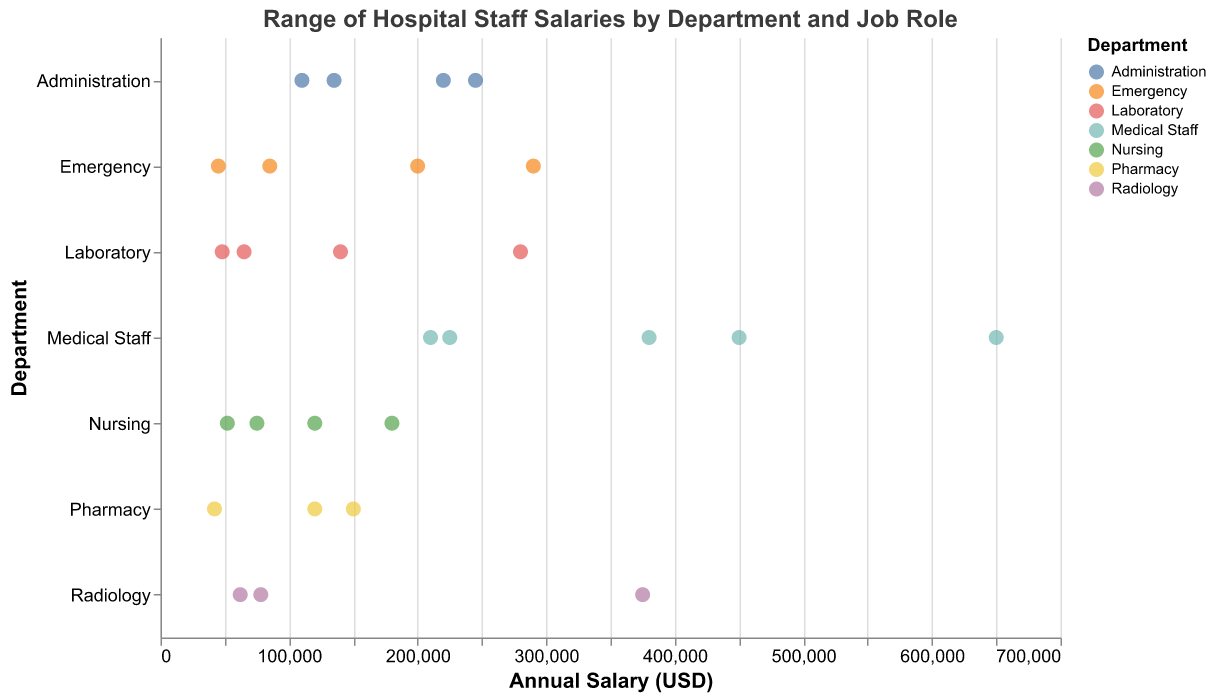What is the annual salary of a Chief Financial Officer in the Administration department? Look at the Administration department row and find the Chief Financial Officer job role, then view the salary value.
Answer: 220000 Which department has the highest-paid job role, and what is the salary? Identify the highest salary in the entire plot and note the department and job role corresponding to it.
Answer: Medical Staff, 650000 What is the range of salaries for the Nursing department? Scan the Nursing department row for the minimum and maximum salary values. The lowest salary is 52000, and the highest is 180000.
Answer: 52000 to 180000 How many job roles in the Laboratory department have an annual salary below 100000? Identify the Laboratory department row and count the number of job roles with salaries below 100000.
Answer: 3 Which department has the lowest-paid job role, and what is the salary? Determine the lowest salary in the entire plot and note the department and job role corresponding to it.
Answer: Emergency, 45000 What is the median salary of all job roles in the Administration department? List the salaries in the Administration department (220000, 245000, 135000, 110000), then find the median value, which means sorting the values and finding the middle point or average of the two middle points.
Answer: 177500 How does the salary of a Radiologist compare to the Chief Medical Officer's salary? Find the salaries of the Radiologist and Chief Medical Officer and compare them. Radiologist earns 375000, and Chief Medical Officer earns 245000.
Answer: Radiologist earns more Are there more job roles with salaries above 200000 in the Emergency department or the Medical Staff department? Count the job roles in both the Emergency and Medical Staff departments with salaries above 200000. Emergency has 1 (ER Physician), Medical Staff has 5.
Answer: Medical Staff Which department shows the widest salary range, and what is the range? Determine the department with the maximum difference between the highest and lowest salary. Medical Staff ranges from 210000 to 650000.
Answer: Medical Staff, 440000 What is the average annual salary of all job roles in the Pharmacy department? Sum the salaries in the Pharmacy department (150000, 120000, 42000) and divide by the number of job roles (3). (150000 + 120000 + 42000) / 3 = 104000
Answer: 104000 